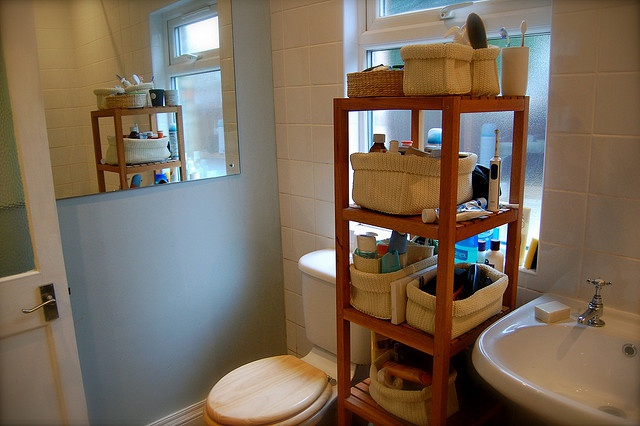Describe the objects in this image and their specific colors. I can see sink in black, gray, and tan tones, toilet in black, tan, gray, and lightgray tones, bottle in black, darkgreen, and maroon tones, bottle in black, gray, and olive tones, and bottle in black, tan, gray, and darkgray tones in this image. 